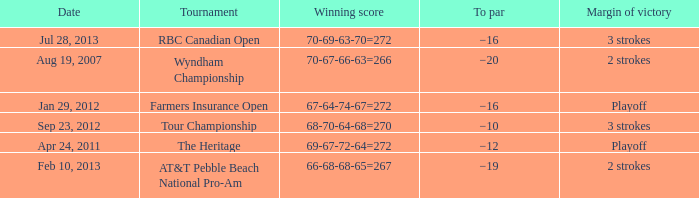What tournament was on Jan 29, 2012? Farmers Insurance Open. 